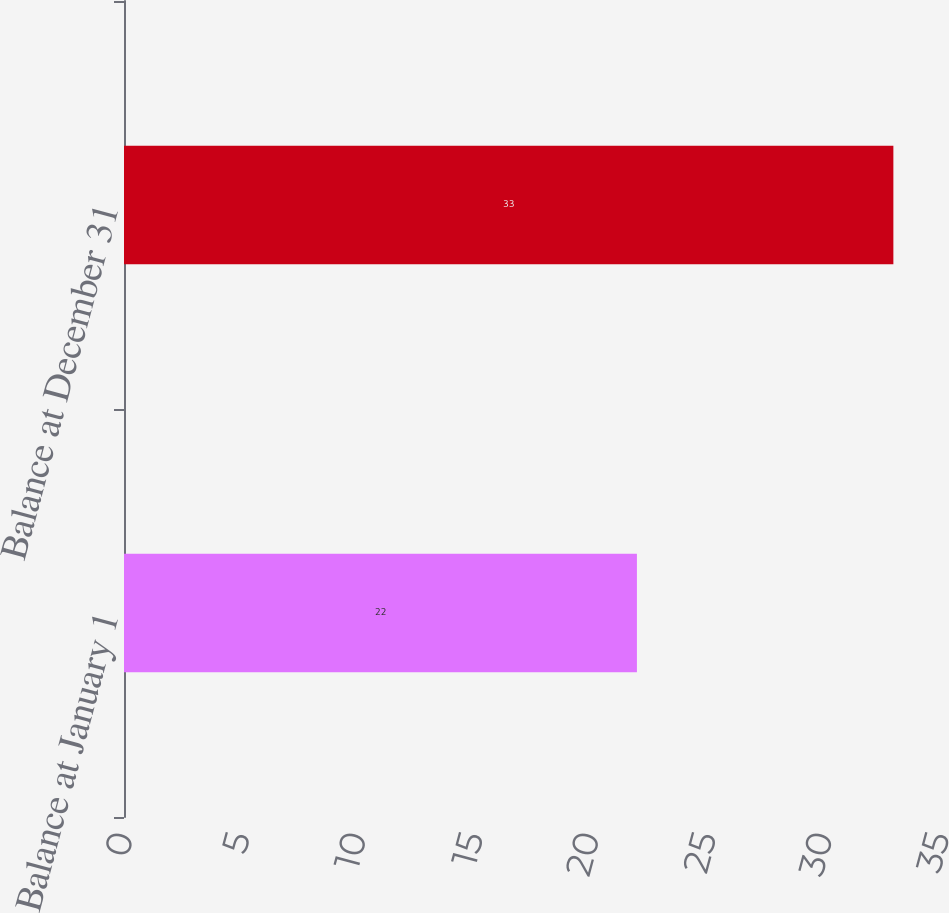Convert chart. <chart><loc_0><loc_0><loc_500><loc_500><bar_chart><fcel>Balance at January 1<fcel>Balance at December 31<nl><fcel>22<fcel>33<nl></chart> 